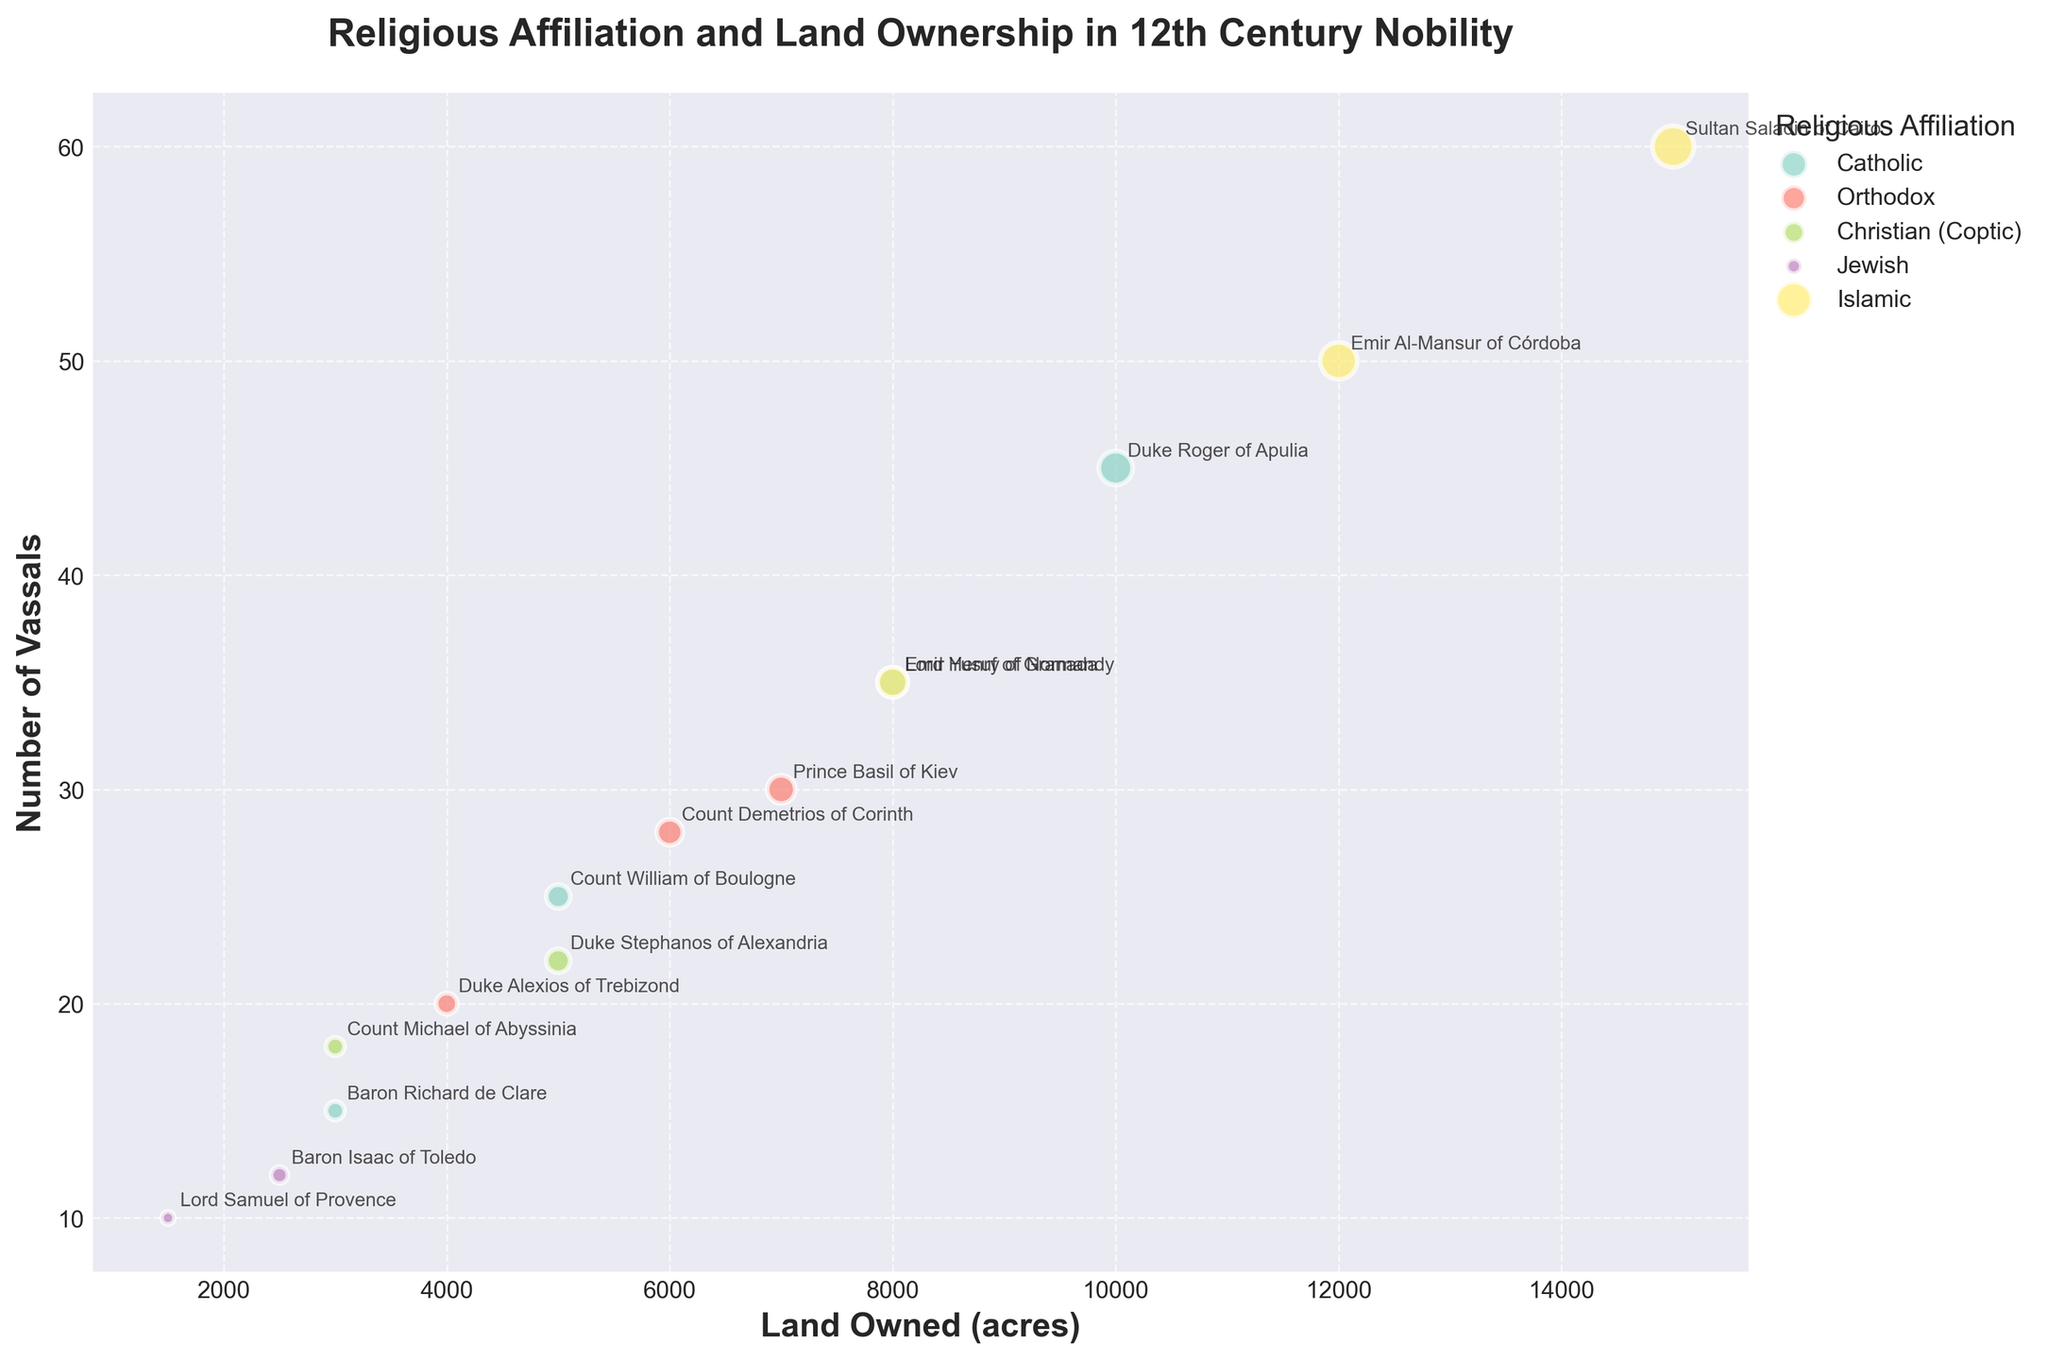What is the title of this bubble chart? The title is usually displayed at the top of the chart. The chart title is "Religious Affiliation and Land Ownership in 12th Century Nobility."
Answer: Religious Affiliation and Land Ownership in 12th Century Nobility How many lords are represented in the bubble chart? Count the number of distinct data points (bubbles) on the chart. Each bubble represents one lord. There are 13 bubbles, indicating 13 lords.
Answer: 13 Which lord has the largest land ownership depicted in the chart? By examining the size of the bubbles, the largest one corresponds to the highest land owned. Sultan Saladin of Cairo has the largest bubble.
Answer: Sultan Saladin of Cairo Which religious affiliation has the most lords represented in the chart? Count the number of bubbles associated with each religion. The Catholic affiliation has the most lords, with 4 lords represented.
Answer: Catholic What is the range of the number of vassals among the Jewish lords? Refer to the bubbles labeled with Jewish lords and note their positions along the y-axis. Lord Samuel of Provence has 10 vassals, and Baron Isaac of Toledo has 12 vassals, so the range is 12 - 10 = 2.
Answer: 2 What is the average amount of land owned by Islamic lords? Identify the land owned by the Islamic lords: Emir Al-Mansur of Córdoba (12000 acres), Emir Yusuf of Granada (8000 acres), and Sultan Saladin of Cairo (15000 acres). Calculate the average as (12000 + 8000 + 15000) / 3 = 35000 / 3 ≈ 11667 acres.
Answer: 11667 acres Which Islamic lord has more vassals, Emir Al-Mansur of Córdoba or Emir Yusuf of Granada? Compare the number of vassals for both lords. Emir Al-Mansur of Córdoba has 50 vassals, and Emir Yusuf of Granada has 35 vassals. Emir Al-Mansur of Córdoba has more vassals.
Answer: Emir Al-Mansur of Córdoba How does the amount of land owned by Orthodox lords compare in size to those of Catholic lords? Compare the sizes of the bubbles for the Orthodox and Catholic lords. Orthodox lords have bubbles of varied sizes like 4000, 6000, and 7000 acres, while Catholic lords have bubbles of 3000, 5000, 8000, and 10000 acres. In general, Catholic lords tend to have larger ranges of land ownership.
Answer: Catholic lords generally have larger ranges of land ownership How are lords annotated in the bubble chart? The lords are annotated with their names next to their corresponding bubbles. For instance, the name "Sultan Saladin of Cairo" is annotated next to the largest bubble.
Answer: With their names 